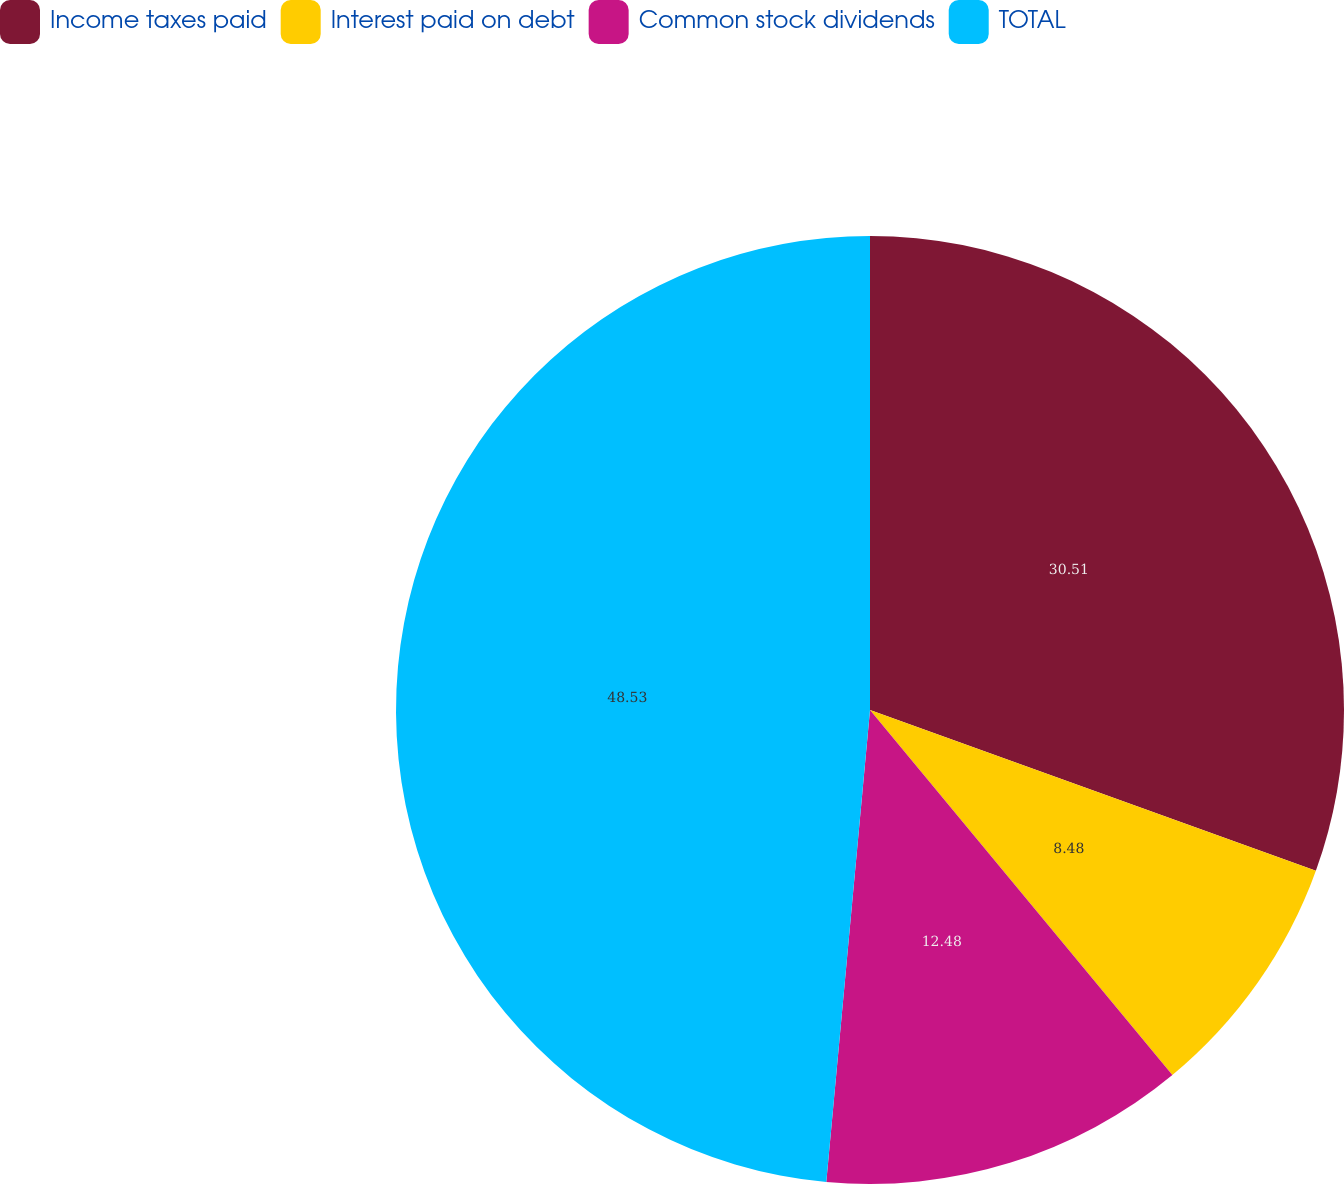<chart> <loc_0><loc_0><loc_500><loc_500><pie_chart><fcel>Income taxes paid<fcel>Interest paid on debt<fcel>Common stock dividends<fcel>TOTAL<nl><fcel>30.51%<fcel>8.48%<fcel>12.48%<fcel>48.53%<nl></chart> 